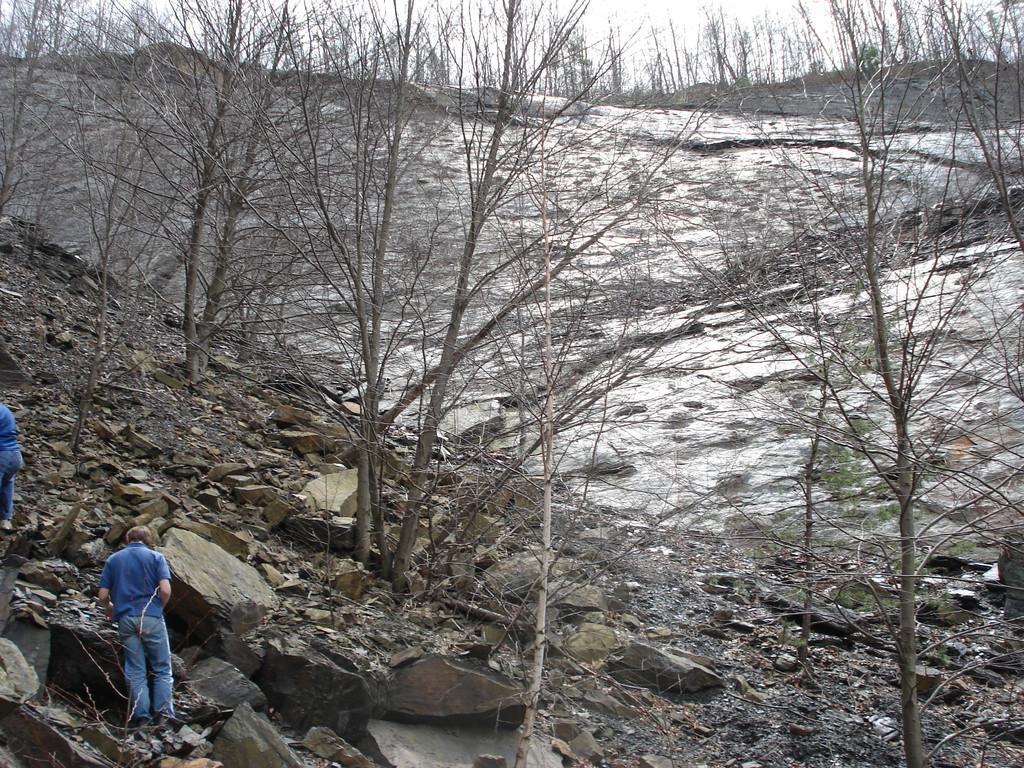Describe this image in one or two sentences. In the bottom left corner there is a man who is wearing blue t-shirt, jeans and shoe. He is standing near to the stones. Beside him there is another man who is wearing the same dress. On the right we can see the trees. In the background we can see mountain and snow. At the top there is a sky. 